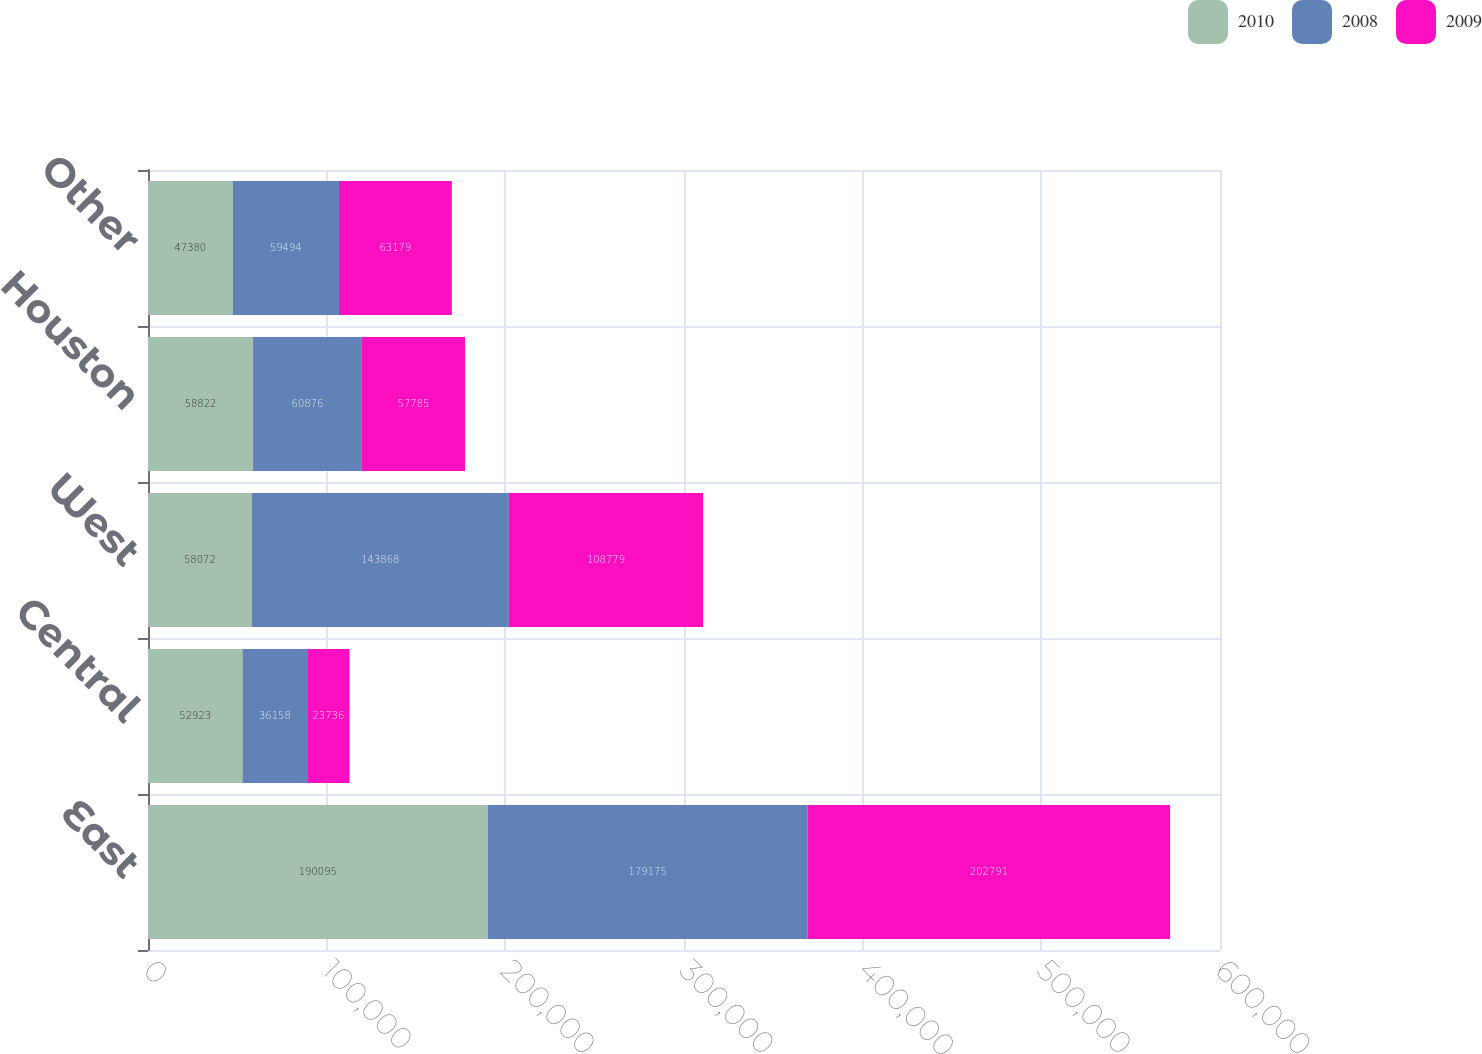<chart> <loc_0><loc_0><loc_500><loc_500><stacked_bar_chart><ecel><fcel>East<fcel>Central<fcel>West<fcel>Houston<fcel>Other<nl><fcel>2010<fcel>190095<fcel>52923<fcel>58072<fcel>58822<fcel>47380<nl><fcel>2008<fcel>179175<fcel>36158<fcel>143868<fcel>60876<fcel>59494<nl><fcel>2009<fcel>202791<fcel>23736<fcel>108779<fcel>57785<fcel>63179<nl></chart> 